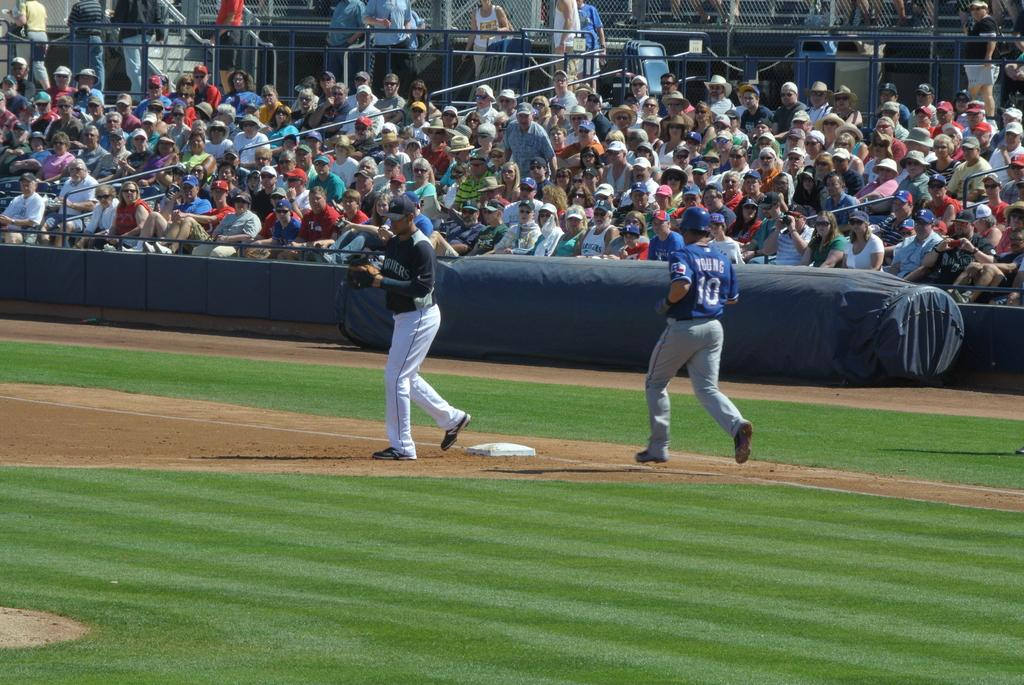How many people are in the image? There are people in the image, but the exact number is not specified. What are some of the people doing in the image? Some people are standing, and some are sitting. What type of surface is visible in the image? There is grass visible in the image. What kind of barrier is present in the image? There is a fence in the image. Can you describe any other objects present in the image? There are other objects present in the image, but their specific nature is not mentioned. How many visitors are present in the image? The term "visitor" is not mentioned in the facts, so it is not possible to determine the number of visitors in the image. 